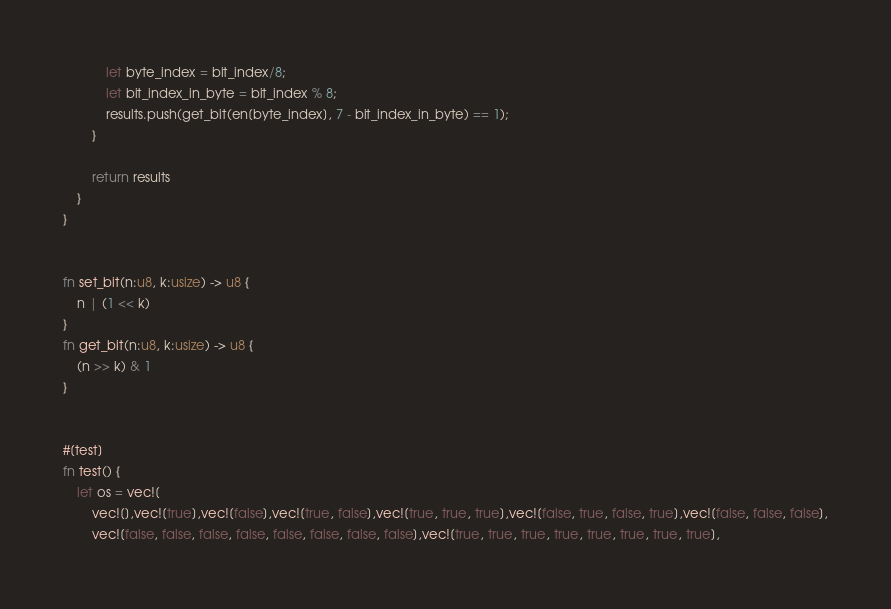Convert code to text. <code><loc_0><loc_0><loc_500><loc_500><_Rust_>            let byte_index = bit_index/8;
            let bit_index_in_byte = bit_index % 8;
            results.push(get_bit(en[byte_index], 7 - bit_index_in_byte) == 1);
        }

        return results
    }
}


fn set_bit(n:u8, k:usize) -> u8 {
    n | (1 << k)
}
fn get_bit(n:u8, k:usize) -> u8 {
    (n >> k) & 1
}


#[test]
fn test() {
    let os = vec![
        vec![],vec![true],vec![false],vec![true, false],vec![true, true, true],vec![false, true, false, true],vec![false, false, false],
        vec![false, false, false, false, false, false, false, false],vec![true, true, true, true, true, true, true, true],</code> 